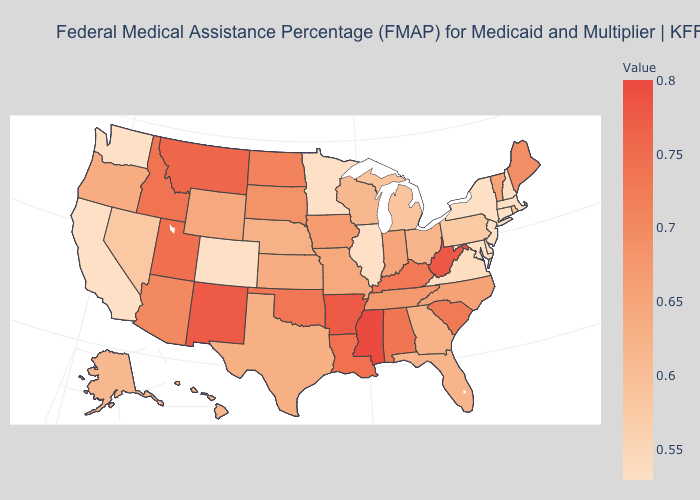Is the legend a continuous bar?
Keep it brief. Yes. Which states hav the highest value in the South?
Write a very short answer. Mississippi. Among the states that border Oklahoma , which have the lowest value?
Answer briefly. Colorado. Does Oregon have a lower value than New Hampshire?
Short answer required. No. 